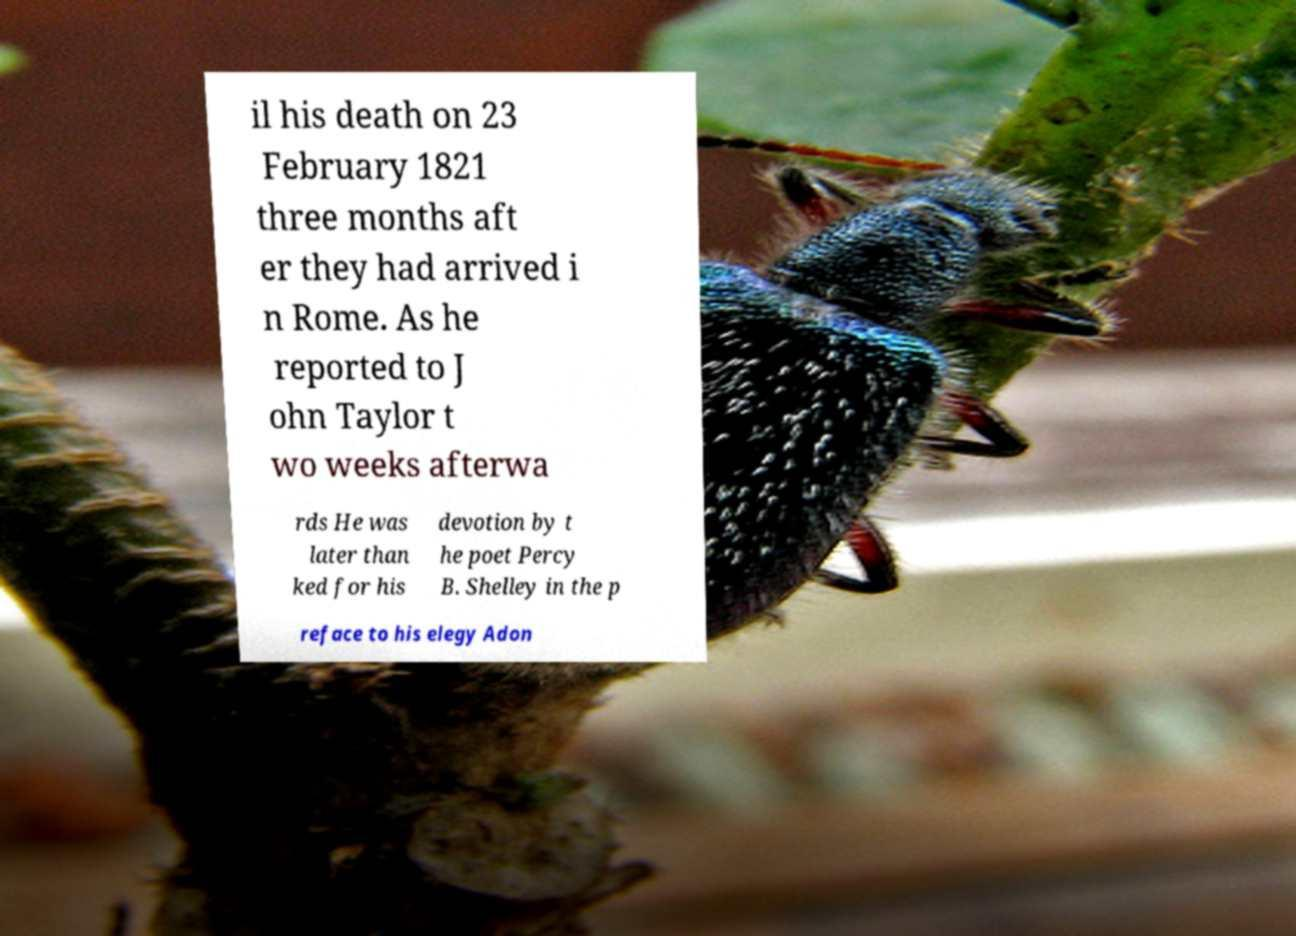Can you accurately transcribe the text from the provided image for me? il his death on 23 February 1821 three months aft er they had arrived i n Rome. As he reported to J ohn Taylor t wo weeks afterwa rds He was later than ked for his devotion by t he poet Percy B. Shelley in the p reface to his elegy Adon 